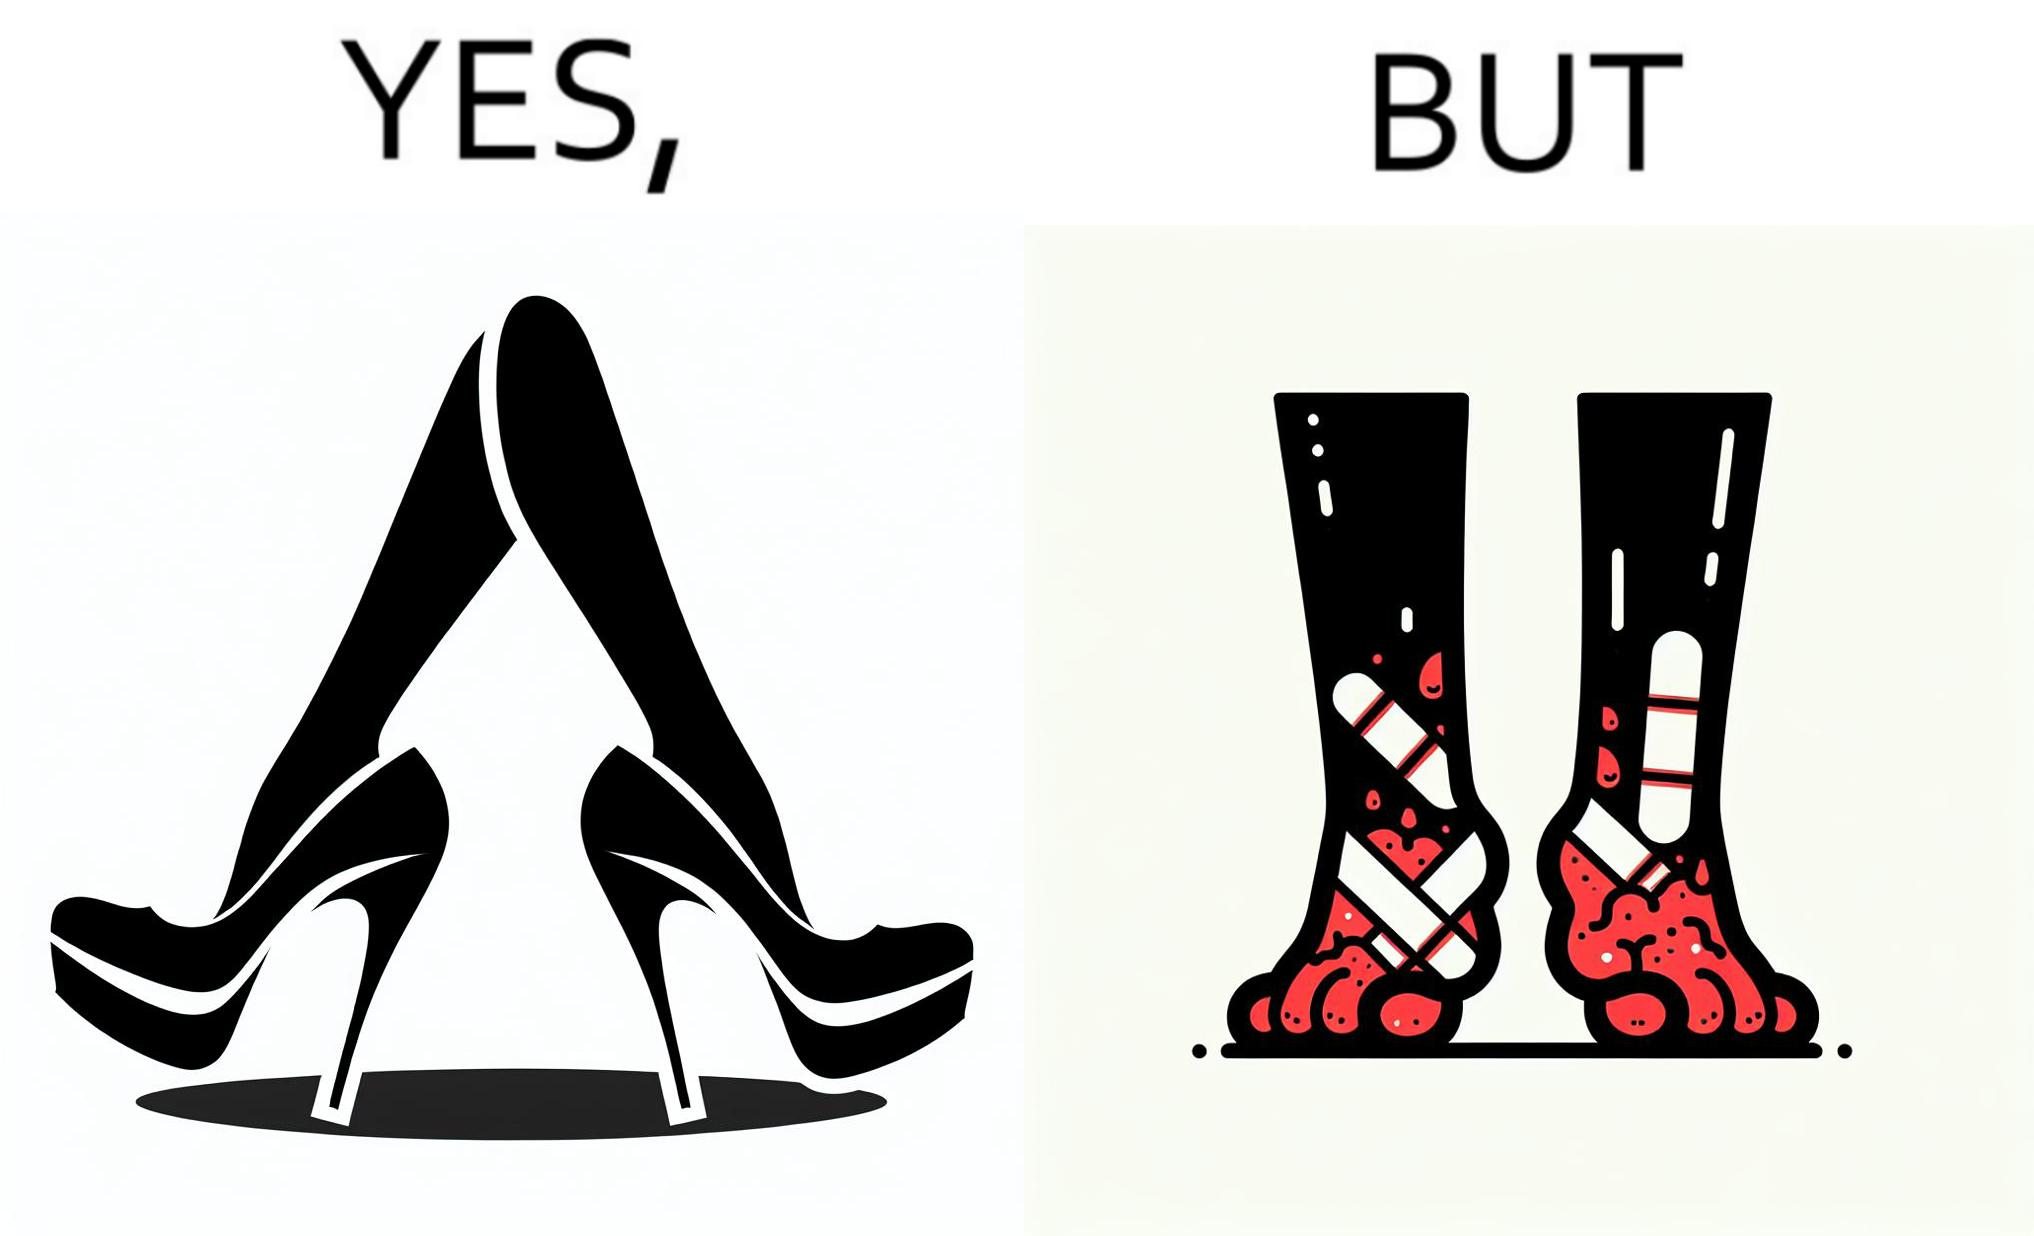What is shown in this image? The images are funny since they show how the prettiest footwears like high heels, end up causing a lot of physical discomfort to the user, all in the name fashion 